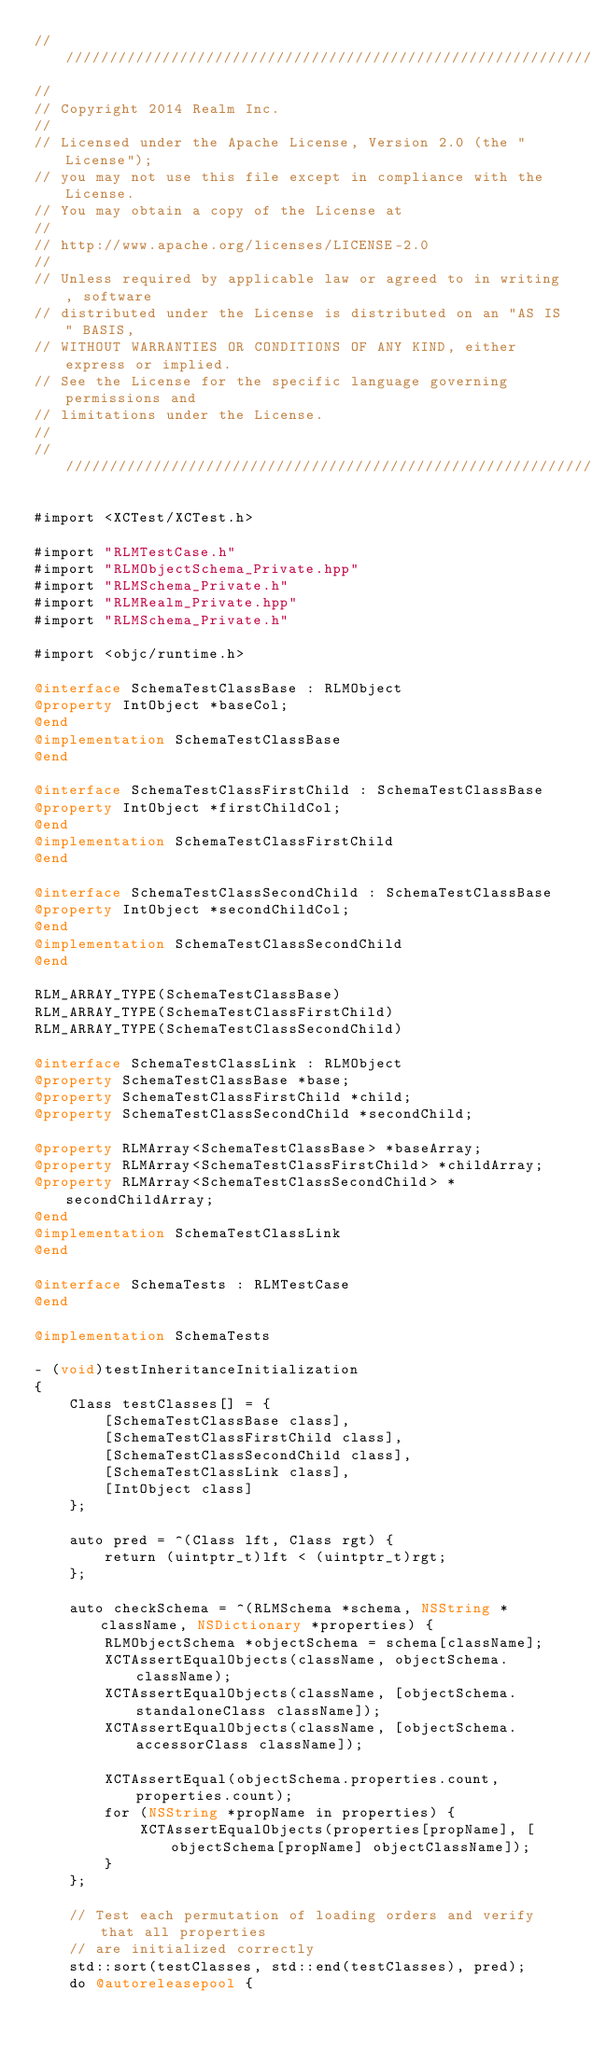<code> <loc_0><loc_0><loc_500><loc_500><_ObjectiveC_>////////////////////////////////////////////////////////////////////////////
//
// Copyright 2014 Realm Inc.
//
// Licensed under the Apache License, Version 2.0 (the "License");
// you may not use this file except in compliance with the License.
// You may obtain a copy of the License at
//
// http://www.apache.org/licenses/LICENSE-2.0
//
// Unless required by applicable law or agreed to in writing, software
// distributed under the License is distributed on an "AS IS" BASIS,
// WITHOUT WARRANTIES OR CONDITIONS OF ANY KIND, either express or implied.
// See the License for the specific language governing permissions and
// limitations under the License.
//
////////////////////////////////////////////////////////////////////////////

#import <XCTest/XCTest.h>

#import "RLMTestCase.h"
#import "RLMObjectSchema_Private.hpp"
#import "RLMSchema_Private.h"
#import "RLMRealm_Private.hpp"
#import "RLMSchema_Private.h"

#import <objc/runtime.h>

@interface SchemaTestClassBase : RLMObject
@property IntObject *baseCol;
@end
@implementation SchemaTestClassBase
@end

@interface SchemaTestClassFirstChild : SchemaTestClassBase
@property IntObject *firstChildCol;
@end
@implementation SchemaTestClassFirstChild
@end

@interface SchemaTestClassSecondChild : SchemaTestClassBase
@property IntObject *secondChildCol;
@end
@implementation SchemaTestClassSecondChild
@end

RLM_ARRAY_TYPE(SchemaTestClassBase)
RLM_ARRAY_TYPE(SchemaTestClassFirstChild)
RLM_ARRAY_TYPE(SchemaTestClassSecondChild)

@interface SchemaTestClassLink : RLMObject
@property SchemaTestClassBase *base;
@property SchemaTestClassFirstChild *child;
@property SchemaTestClassSecondChild *secondChild;

@property RLMArray<SchemaTestClassBase> *baseArray;
@property RLMArray<SchemaTestClassFirstChild> *childArray;
@property RLMArray<SchemaTestClassSecondChild> *secondChildArray;
@end
@implementation SchemaTestClassLink
@end

@interface SchemaTests : RLMTestCase
@end

@implementation SchemaTests

- (void)testInheritanceInitialization
{
    Class testClasses[] = {
        [SchemaTestClassBase class],
        [SchemaTestClassFirstChild class],
        [SchemaTestClassSecondChild class],
        [SchemaTestClassLink class],
        [IntObject class]
    };

    auto pred = ^(Class lft, Class rgt) {
        return (uintptr_t)lft < (uintptr_t)rgt;
    };

    auto checkSchema = ^(RLMSchema *schema, NSString *className, NSDictionary *properties) {
        RLMObjectSchema *objectSchema = schema[className];
        XCTAssertEqualObjects(className, objectSchema.className);
        XCTAssertEqualObjects(className, [objectSchema.standaloneClass className]);
        XCTAssertEqualObjects(className, [objectSchema.accessorClass className]);

        XCTAssertEqual(objectSchema.properties.count, properties.count);
        for (NSString *propName in properties) {
            XCTAssertEqualObjects(properties[propName], [objectSchema[propName] objectClassName]);
        }
    };

    // Test each permutation of loading orders and verify that all properties
    // are initialized correctly
    std::sort(testClasses, std::end(testClasses), pred);
    do @autoreleasepool {</code> 